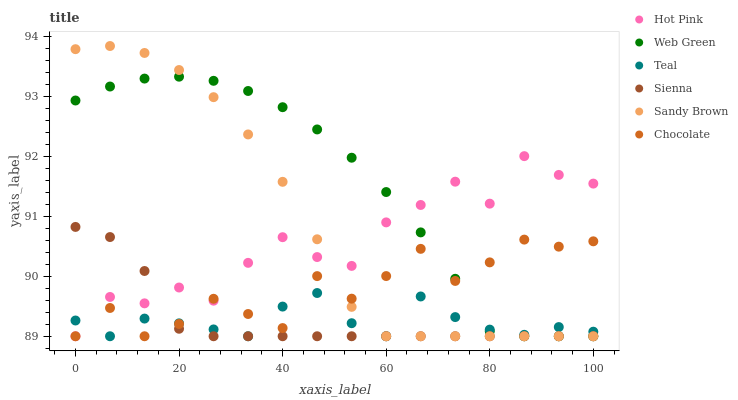Does Teal have the minimum area under the curve?
Answer yes or no. Yes. Does Web Green have the maximum area under the curve?
Answer yes or no. Yes. Does Chocolate have the minimum area under the curve?
Answer yes or no. No. Does Chocolate have the maximum area under the curve?
Answer yes or no. No. Is Sienna the smoothest?
Answer yes or no. Yes. Is Chocolate the roughest?
Answer yes or no. Yes. Is Web Green the smoothest?
Answer yes or no. No. Is Web Green the roughest?
Answer yes or no. No. Does Hot Pink have the lowest value?
Answer yes or no. Yes. Does Sandy Brown have the highest value?
Answer yes or no. Yes. Does Web Green have the highest value?
Answer yes or no. No. Does Chocolate intersect Hot Pink?
Answer yes or no. Yes. Is Chocolate less than Hot Pink?
Answer yes or no. No. Is Chocolate greater than Hot Pink?
Answer yes or no. No. 